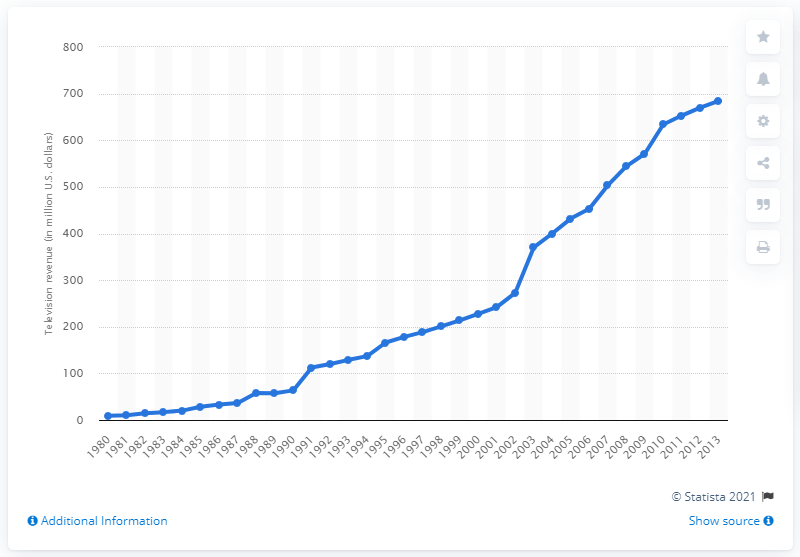Identify some key points in this picture. In 2010, the television revenue was 633.8 million dollars. 